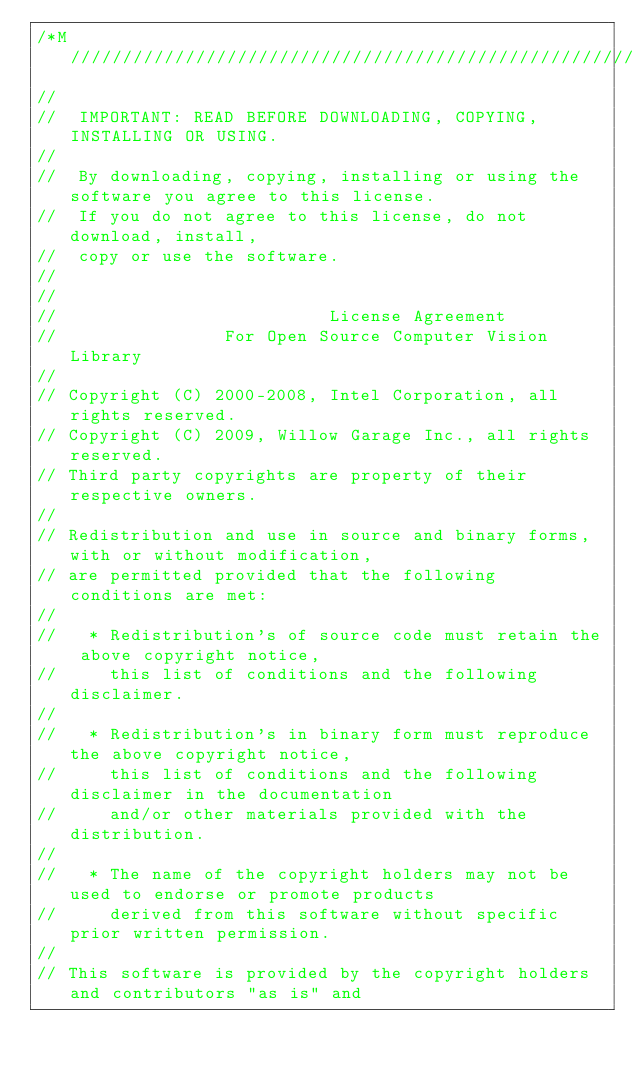Convert code to text. <code><loc_0><loc_0><loc_500><loc_500><_C++_>/*M///////////////////////////////////////////////////////////////////////////////////////
//
//  IMPORTANT: READ BEFORE DOWNLOADING, COPYING, INSTALLING OR USING.
//
//  By downloading, copying, installing or using the software you agree to this license.
//  If you do not agree to this license, do not download, install,
//  copy or use the software.
//
//
//                          License Agreement
//                For Open Source Computer Vision Library
//
// Copyright (C) 2000-2008, Intel Corporation, all rights reserved.
// Copyright (C) 2009, Willow Garage Inc., all rights reserved.
// Third party copyrights are property of their respective owners.
//
// Redistribution and use in source and binary forms, with or without modification,
// are permitted provided that the following conditions are met:
//
//   * Redistribution's of source code must retain the above copyright notice,
//     this list of conditions and the following disclaimer.
//
//   * Redistribution's in binary form must reproduce the above copyright notice,
//     this list of conditions and the following disclaimer in the documentation
//     and/or other materials provided with the distribution.
//
//   * The name of the copyright holders may not be used to endorse or promote products
//     derived from this software without specific prior written permission.
//
// This software is provided by the copyright holders and contributors "as is" and</code> 